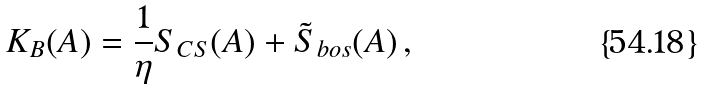<formula> <loc_0><loc_0><loc_500><loc_500>K _ { B } ( A ) = \frac { 1 } { \eta } S _ { C S } ( A ) + \tilde { S } _ { b o s } ( A ) \, ,</formula> 